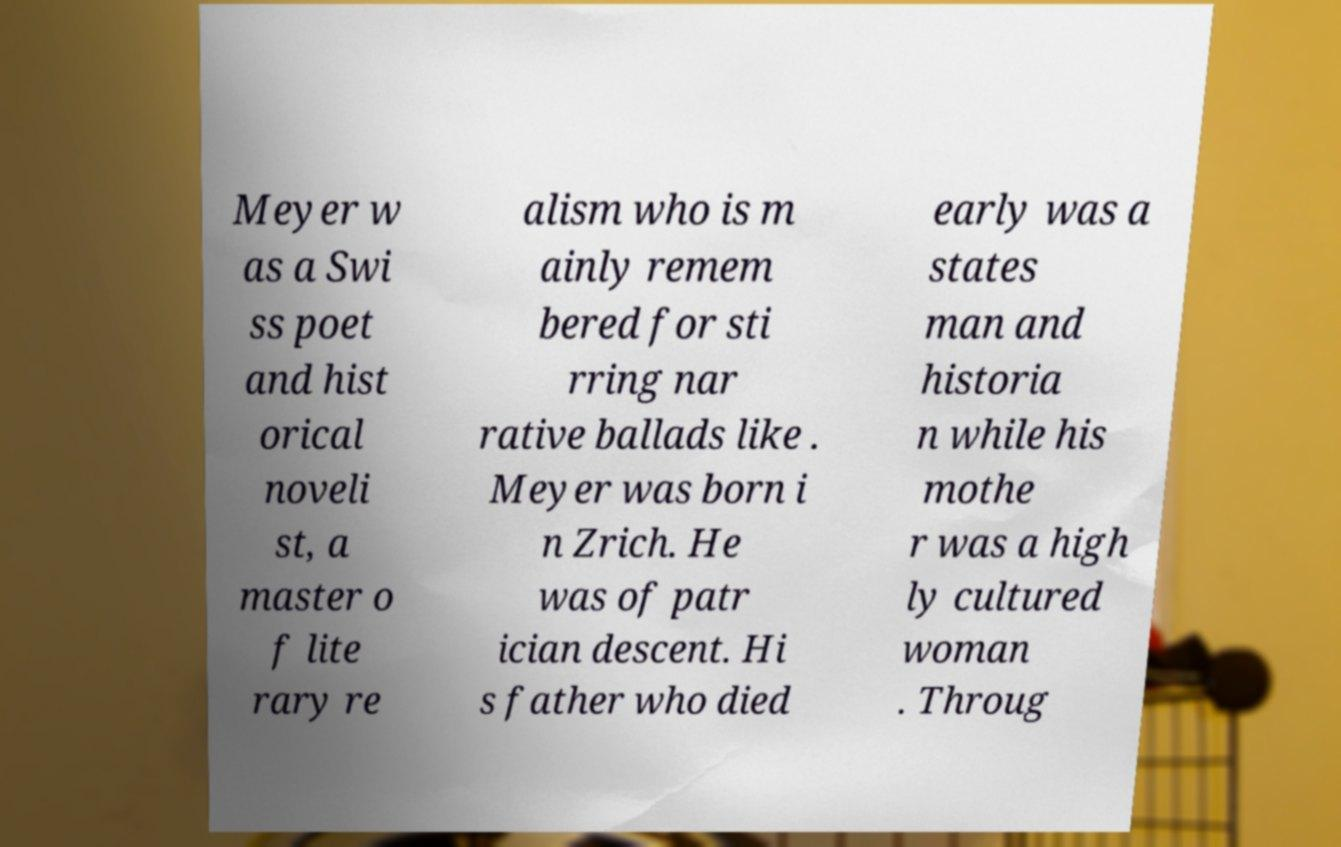Could you assist in decoding the text presented in this image and type it out clearly? Meyer w as a Swi ss poet and hist orical noveli st, a master o f lite rary re alism who is m ainly remem bered for sti rring nar rative ballads like . Meyer was born i n Zrich. He was of patr ician descent. Hi s father who died early was a states man and historia n while his mothe r was a high ly cultured woman . Throug 